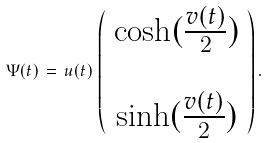<formula> <loc_0><loc_0><loc_500><loc_500>\Psi ( t ) \, = \, u ( t ) \, \left ( \begin{array} { c } \cosh ( \frac { v ( t ) } { 2 } ) \\ \, \\ \sinh ( \frac { v ( t ) } { 2 } ) \end{array} \right ) .</formula> 